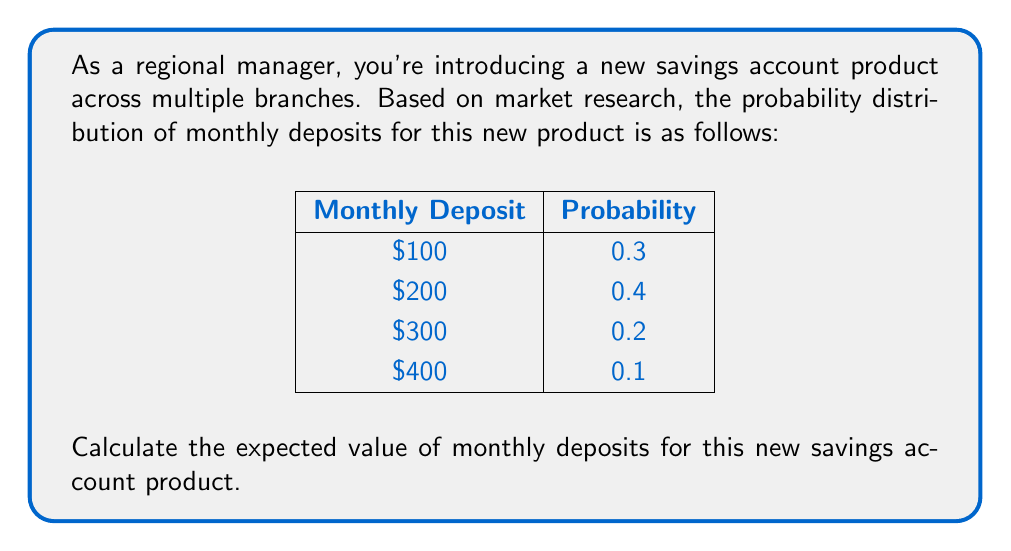Help me with this question. To calculate the expected value, we need to follow these steps:

1) The expected value is calculated by multiplying each possible outcome by its probability and then summing these products.

2) Let's denote the expected value as $E(X)$. The formula is:

   $E(X) = \sum_{i=1}^{n} x_i \cdot p(x_i)$

   where $x_i$ is each possible outcome and $p(x_i)$ is its probability.

3) Let's calculate each term:
   
   For $\$100$: $100 \cdot 0.3 = 30$
   For $\$200$: $200 \cdot 0.4 = 80$
   For $\$300$: $300 \cdot 0.2 = 60$
   For $\$400$: $400 \cdot 0.1 = 40$

4) Now, let's sum these values:

   $E(X) = 30 + 80 + 60 + 40 = 210$

Therefore, the expected value of monthly deposits for the new savings account product is $\$210$.
Answer: $\$210$ 